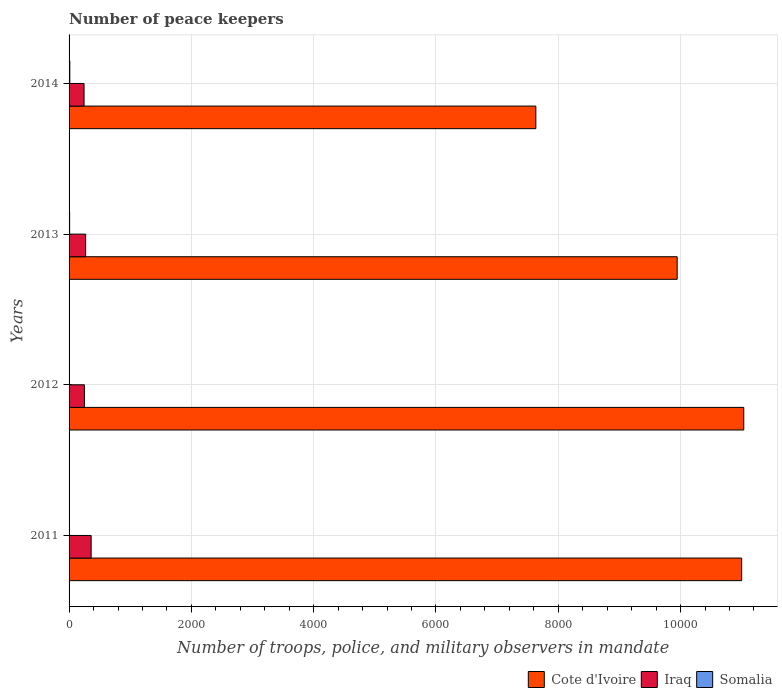How many different coloured bars are there?
Provide a succinct answer. 3. How many groups of bars are there?
Make the answer very short. 4. Are the number of bars per tick equal to the number of legend labels?
Your answer should be compact. Yes. Are the number of bars on each tick of the Y-axis equal?
Your response must be concise. Yes. How many bars are there on the 2nd tick from the top?
Your answer should be compact. 3. How many bars are there on the 3rd tick from the bottom?
Offer a terse response. 3. What is the label of the 4th group of bars from the top?
Offer a very short reply. 2011. In how many cases, is the number of bars for a given year not equal to the number of legend labels?
Your response must be concise. 0. What is the number of peace keepers in in Somalia in 2014?
Keep it short and to the point. 12. Across all years, what is the minimum number of peace keepers in in Iraq?
Your answer should be very brief. 245. In which year was the number of peace keepers in in Iraq maximum?
Your answer should be very brief. 2011. In which year was the number of peace keepers in in Somalia minimum?
Your answer should be compact. 2012. What is the total number of peace keepers in in Somalia in the graph?
Ensure brevity in your answer.  30. What is the difference between the number of peace keepers in in Cote d'Ivoire in 2012 and that in 2014?
Your response must be concise. 3400. What is the difference between the number of peace keepers in in Iraq in 2014 and the number of peace keepers in in Somalia in 2013?
Give a very brief answer. 236. What is the average number of peace keepers in in Iraq per year?
Your answer should be compact. 282. In the year 2013, what is the difference between the number of peace keepers in in Cote d'Ivoire and number of peace keepers in in Somalia?
Keep it short and to the point. 9935. What is the ratio of the number of peace keepers in in Cote d'Ivoire in 2012 to that in 2013?
Offer a very short reply. 1.11. Is the difference between the number of peace keepers in in Cote d'Ivoire in 2011 and 2013 greater than the difference between the number of peace keepers in in Somalia in 2011 and 2013?
Ensure brevity in your answer.  Yes. What is the difference between the highest and the second highest number of peace keepers in in Somalia?
Offer a terse response. 3. In how many years, is the number of peace keepers in in Somalia greater than the average number of peace keepers in in Somalia taken over all years?
Your answer should be very brief. 2. What does the 1st bar from the top in 2014 represents?
Your answer should be compact. Somalia. What does the 1st bar from the bottom in 2012 represents?
Your answer should be very brief. Cote d'Ivoire. Is it the case that in every year, the sum of the number of peace keepers in in Cote d'Ivoire and number of peace keepers in in Somalia is greater than the number of peace keepers in in Iraq?
Make the answer very short. Yes. How many bars are there?
Keep it short and to the point. 12. What is the difference between two consecutive major ticks on the X-axis?
Your answer should be compact. 2000. Where does the legend appear in the graph?
Keep it short and to the point. Bottom right. How are the legend labels stacked?
Give a very brief answer. Horizontal. What is the title of the graph?
Provide a succinct answer. Number of peace keepers. What is the label or title of the X-axis?
Offer a terse response. Number of troops, police, and military observers in mandate. What is the Number of troops, police, and military observers in mandate of Cote d'Ivoire in 2011?
Provide a short and direct response. 1.10e+04. What is the Number of troops, police, and military observers in mandate in Iraq in 2011?
Offer a very short reply. 361. What is the Number of troops, police, and military observers in mandate in Cote d'Ivoire in 2012?
Give a very brief answer. 1.10e+04. What is the Number of troops, police, and military observers in mandate in Iraq in 2012?
Provide a succinct answer. 251. What is the Number of troops, police, and military observers in mandate in Somalia in 2012?
Provide a short and direct response. 3. What is the Number of troops, police, and military observers in mandate in Cote d'Ivoire in 2013?
Ensure brevity in your answer.  9944. What is the Number of troops, police, and military observers in mandate in Iraq in 2013?
Make the answer very short. 271. What is the Number of troops, police, and military observers in mandate in Cote d'Ivoire in 2014?
Provide a succinct answer. 7633. What is the Number of troops, police, and military observers in mandate of Iraq in 2014?
Your answer should be compact. 245. Across all years, what is the maximum Number of troops, police, and military observers in mandate of Cote d'Ivoire?
Offer a terse response. 1.10e+04. Across all years, what is the maximum Number of troops, police, and military observers in mandate of Iraq?
Give a very brief answer. 361. Across all years, what is the minimum Number of troops, police, and military observers in mandate in Cote d'Ivoire?
Provide a succinct answer. 7633. Across all years, what is the minimum Number of troops, police, and military observers in mandate in Iraq?
Provide a short and direct response. 245. What is the total Number of troops, police, and military observers in mandate of Cote d'Ivoire in the graph?
Give a very brief answer. 3.96e+04. What is the total Number of troops, police, and military observers in mandate of Iraq in the graph?
Your response must be concise. 1128. What is the difference between the Number of troops, police, and military observers in mandate in Cote d'Ivoire in 2011 and that in 2012?
Ensure brevity in your answer.  -34. What is the difference between the Number of troops, police, and military observers in mandate of Iraq in 2011 and that in 2012?
Offer a terse response. 110. What is the difference between the Number of troops, police, and military observers in mandate in Somalia in 2011 and that in 2012?
Your answer should be compact. 3. What is the difference between the Number of troops, police, and military observers in mandate of Cote d'Ivoire in 2011 and that in 2013?
Give a very brief answer. 1055. What is the difference between the Number of troops, police, and military observers in mandate in Iraq in 2011 and that in 2013?
Your response must be concise. 90. What is the difference between the Number of troops, police, and military observers in mandate in Somalia in 2011 and that in 2013?
Offer a terse response. -3. What is the difference between the Number of troops, police, and military observers in mandate of Cote d'Ivoire in 2011 and that in 2014?
Give a very brief answer. 3366. What is the difference between the Number of troops, police, and military observers in mandate of Iraq in 2011 and that in 2014?
Your answer should be compact. 116. What is the difference between the Number of troops, police, and military observers in mandate of Somalia in 2011 and that in 2014?
Provide a succinct answer. -6. What is the difference between the Number of troops, police, and military observers in mandate of Cote d'Ivoire in 2012 and that in 2013?
Ensure brevity in your answer.  1089. What is the difference between the Number of troops, police, and military observers in mandate of Somalia in 2012 and that in 2013?
Provide a short and direct response. -6. What is the difference between the Number of troops, police, and military observers in mandate of Cote d'Ivoire in 2012 and that in 2014?
Ensure brevity in your answer.  3400. What is the difference between the Number of troops, police, and military observers in mandate of Iraq in 2012 and that in 2014?
Offer a very short reply. 6. What is the difference between the Number of troops, police, and military observers in mandate of Somalia in 2012 and that in 2014?
Offer a very short reply. -9. What is the difference between the Number of troops, police, and military observers in mandate in Cote d'Ivoire in 2013 and that in 2014?
Your answer should be very brief. 2311. What is the difference between the Number of troops, police, and military observers in mandate of Iraq in 2013 and that in 2014?
Provide a short and direct response. 26. What is the difference between the Number of troops, police, and military observers in mandate of Somalia in 2013 and that in 2014?
Provide a short and direct response. -3. What is the difference between the Number of troops, police, and military observers in mandate in Cote d'Ivoire in 2011 and the Number of troops, police, and military observers in mandate in Iraq in 2012?
Make the answer very short. 1.07e+04. What is the difference between the Number of troops, police, and military observers in mandate of Cote d'Ivoire in 2011 and the Number of troops, police, and military observers in mandate of Somalia in 2012?
Provide a short and direct response. 1.10e+04. What is the difference between the Number of troops, police, and military observers in mandate in Iraq in 2011 and the Number of troops, police, and military observers in mandate in Somalia in 2012?
Give a very brief answer. 358. What is the difference between the Number of troops, police, and military observers in mandate in Cote d'Ivoire in 2011 and the Number of troops, police, and military observers in mandate in Iraq in 2013?
Your response must be concise. 1.07e+04. What is the difference between the Number of troops, police, and military observers in mandate in Cote d'Ivoire in 2011 and the Number of troops, police, and military observers in mandate in Somalia in 2013?
Provide a short and direct response. 1.10e+04. What is the difference between the Number of troops, police, and military observers in mandate of Iraq in 2011 and the Number of troops, police, and military observers in mandate of Somalia in 2013?
Provide a short and direct response. 352. What is the difference between the Number of troops, police, and military observers in mandate of Cote d'Ivoire in 2011 and the Number of troops, police, and military observers in mandate of Iraq in 2014?
Provide a short and direct response. 1.08e+04. What is the difference between the Number of troops, police, and military observers in mandate in Cote d'Ivoire in 2011 and the Number of troops, police, and military observers in mandate in Somalia in 2014?
Ensure brevity in your answer.  1.10e+04. What is the difference between the Number of troops, police, and military observers in mandate of Iraq in 2011 and the Number of troops, police, and military observers in mandate of Somalia in 2014?
Offer a terse response. 349. What is the difference between the Number of troops, police, and military observers in mandate in Cote d'Ivoire in 2012 and the Number of troops, police, and military observers in mandate in Iraq in 2013?
Keep it short and to the point. 1.08e+04. What is the difference between the Number of troops, police, and military observers in mandate of Cote d'Ivoire in 2012 and the Number of troops, police, and military observers in mandate of Somalia in 2013?
Your answer should be very brief. 1.10e+04. What is the difference between the Number of troops, police, and military observers in mandate of Iraq in 2012 and the Number of troops, police, and military observers in mandate of Somalia in 2013?
Your answer should be compact. 242. What is the difference between the Number of troops, police, and military observers in mandate in Cote d'Ivoire in 2012 and the Number of troops, police, and military observers in mandate in Iraq in 2014?
Provide a succinct answer. 1.08e+04. What is the difference between the Number of troops, police, and military observers in mandate of Cote d'Ivoire in 2012 and the Number of troops, police, and military observers in mandate of Somalia in 2014?
Your answer should be compact. 1.10e+04. What is the difference between the Number of troops, police, and military observers in mandate of Iraq in 2012 and the Number of troops, police, and military observers in mandate of Somalia in 2014?
Ensure brevity in your answer.  239. What is the difference between the Number of troops, police, and military observers in mandate in Cote d'Ivoire in 2013 and the Number of troops, police, and military observers in mandate in Iraq in 2014?
Offer a terse response. 9699. What is the difference between the Number of troops, police, and military observers in mandate of Cote d'Ivoire in 2013 and the Number of troops, police, and military observers in mandate of Somalia in 2014?
Keep it short and to the point. 9932. What is the difference between the Number of troops, police, and military observers in mandate of Iraq in 2013 and the Number of troops, police, and military observers in mandate of Somalia in 2014?
Offer a terse response. 259. What is the average Number of troops, police, and military observers in mandate of Cote d'Ivoire per year?
Your response must be concise. 9902.25. What is the average Number of troops, police, and military observers in mandate of Iraq per year?
Offer a terse response. 282. What is the average Number of troops, police, and military observers in mandate in Somalia per year?
Keep it short and to the point. 7.5. In the year 2011, what is the difference between the Number of troops, police, and military observers in mandate in Cote d'Ivoire and Number of troops, police, and military observers in mandate in Iraq?
Provide a short and direct response. 1.06e+04. In the year 2011, what is the difference between the Number of troops, police, and military observers in mandate in Cote d'Ivoire and Number of troops, police, and military observers in mandate in Somalia?
Your answer should be compact. 1.10e+04. In the year 2011, what is the difference between the Number of troops, police, and military observers in mandate of Iraq and Number of troops, police, and military observers in mandate of Somalia?
Make the answer very short. 355. In the year 2012, what is the difference between the Number of troops, police, and military observers in mandate of Cote d'Ivoire and Number of troops, police, and military observers in mandate of Iraq?
Your response must be concise. 1.08e+04. In the year 2012, what is the difference between the Number of troops, police, and military observers in mandate of Cote d'Ivoire and Number of troops, police, and military observers in mandate of Somalia?
Ensure brevity in your answer.  1.10e+04. In the year 2012, what is the difference between the Number of troops, police, and military observers in mandate in Iraq and Number of troops, police, and military observers in mandate in Somalia?
Provide a short and direct response. 248. In the year 2013, what is the difference between the Number of troops, police, and military observers in mandate of Cote d'Ivoire and Number of troops, police, and military observers in mandate of Iraq?
Provide a succinct answer. 9673. In the year 2013, what is the difference between the Number of troops, police, and military observers in mandate in Cote d'Ivoire and Number of troops, police, and military observers in mandate in Somalia?
Give a very brief answer. 9935. In the year 2013, what is the difference between the Number of troops, police, and military observers in mandate in Iraq and Number of troops, police, and military observers in mandate in Somalia?
Keep it short and to the point. 262. In the year 2014, what is the difference between the Number of troops, police, and military observers in mandate in Cote d'Ivoire and Number of troops, police, and military observers in mandate in Iraq?
Your response must be concise. 7388. In the year 2014, what is the difference between the Number of troops, police, and military observers in mandate in Cote d'Ivoire and Number of troops, police, and military observers in mandate in Somalia?
Give a very brief answer. 7621. In the year 2014, what is the difference between the Number of troops, police, and military observers in mandate of Iraq and Number of troops, police, and military observers in mandate of Somalia?
Offer a very short reply. 233. What is the ratio of the Number of troops, police, and military observers in mandate in Iraq in 2011 to that in 2012?
Your answer should be compact. 1.44. What is the ratio of the Number of troops, police, and military observers in mandate in Cote d'Ivoire in 2011 to that in 2013?
Your response must be concise. 1.11. What is the ratio of the Number of troops, police, and military observers in mandate in Iraq in 2011 to that in 2013?
Offer a terse response. 1.33. What is the ratio of the Number of troops, police, and military observers in mandate in Cote d'Ivoire in 2011 to that in 2014?
Ensure brevity in your answer.  1.44. What is the ratio of the Number of troops, police, and military observers in mandate of Iraq in 2011 to that in 2014?
Give a very brief answer. 1.47. What is the ratio of the Number of troops, police, and military observers in mandate of Somalia in 2011 to that in 2014?
Your response must be concise. 0.5. What is the ratio of the Number of troops, police, and military observers in mandate of Cote d'Ivoire in 2012 to that in 2013?
Make the answer very short. 1.11. What is the ratio of the Number of troops, police, and military observers in mandate of Iraq in 2012 to that in 2013?
Your response must be concise. 0.93. What is the ratio of the Number of troops, police, and military observers in mandate of Somalia in 2012 to that in 2013?
Keep it short and to the point. 0.33. What is the ratio of the Number of troops, police, and military observers in mandate of Cote d'Ivoire in 2012 to that in 2014?
Provide a short and direct response. 1.45. What is the ratio of the Number of troops, police, and military observers in mandate in Iraq in 2012 to that in 2014?
Offer a terse response. 1.02. What is the ratio of the Number of troops, police, and military observers in mandate in Cote d'Ivoire in 2013 to that in 2014?
Make the answer very short. 1.3. What is the ratio of the Number of troops, police, and military observers in mandate in Iraq in 2013 to that in 2014?
Provide a short and direct response. 1.11. What is the ratio of the Number of troops, police, and military observers in mandate in Somalia in 2013 to that in 2014?
Provide a short and direct response. 0.75. What is the difference between the highest and the second highest Number of troops, police, and military observers in mandate in Cote d'Ivoire?
Offer a terse response. 34. What is the difference between the highest and the lowest Number of troops, police, and military observers in mandate in Cote d'Ivoire?
Your response must be concise. 3400. What is the difference between the highest and the lowest Number of troops, police, and military observers in mandate of Iraq?
Offer a very short reply. 116. What is the difference between the highest and the lowest Number of troops, police, and military observers in mandate of Somalia?
Give a very brief answer. 9. 